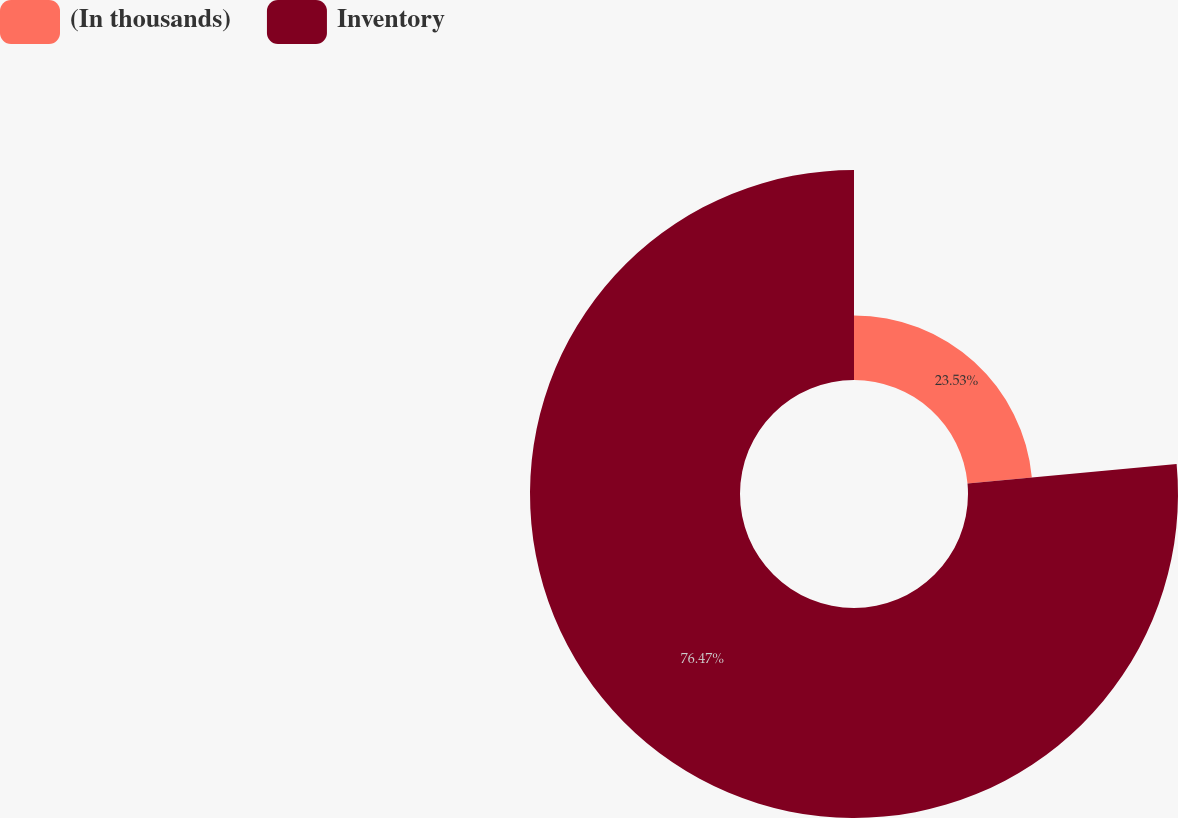Convert chart. <chart><loc_0><loc_0><loc_500><loc_500><pie_chart><fcel>(In thousands)<fcel>Inventory<nl><fcel>23.53%<fcel>76.47%<nl></chart> 